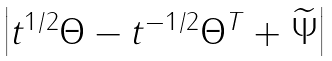Convert formula to latex. <formula><loc_0><loc_0><loc_500><loc_500>\begin{vmatrix} t ^ { 1 / 2 } \Theta - t ^ { - 1 / 2 } \Theta ^ { T } + \widetilde { \Psi } \end{vmatrix}</formula> 